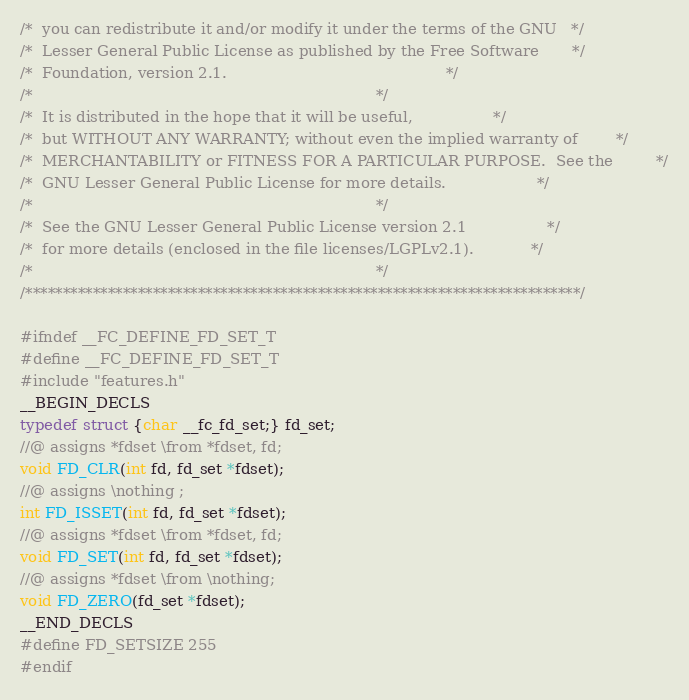Convert code to text. <code><loc_0><loc_0><loc_500><loc_500><_C_>/*  you can redistribute it and/or modify it under the terms of the GNU   */
/*  Lesser General Public License as published by the Free Software       */
/*  Foundation, version 2.1.                                              */
/*                                                                        */
/*  It is distributed in the hope that it will be useful,                 */
/*  but WITHOUT ANY WARRANTY; without even the implied warranty of        */
/*  MERCHANTABILITY or FITNESS FOR A PARTICULAR PURPOSE.  See the         */
/*  GNU Lesser General Public License for more details.                   */
/*                                                                        */
/*  See the GNU Lesser General Public License version 2.1                 */
/*  for more details (enclosed in the file licenses/LGPLv2.1).            */
/*                                                                        */
/**************************************************************************/

#ifndef __FC_DEFINE_FD_SET_T
#define __FC_DEFINE_FD_SET_T
#include "features.h"
__BEGIN_DECLS
typedef struct {char __fc_fd_set;} fd_set;
//@ assigns *fdset \from *fdset, fd;
void FD_CLR(int fd, fd_set *fdset);
//@ assigns \nothing ;
int FD_ISSET(int fd, fd_set *fdset);
//@ assigns *fdset \from *fdset, fd;
void FD_SET(int fd, fd_set *fdset);
//@ assigns *fdset \from \nothing;
void FD_ZERO(fd_set *fdset);
__END_DECLS
#define FD_SETSIZE 255
#endif
</code> 